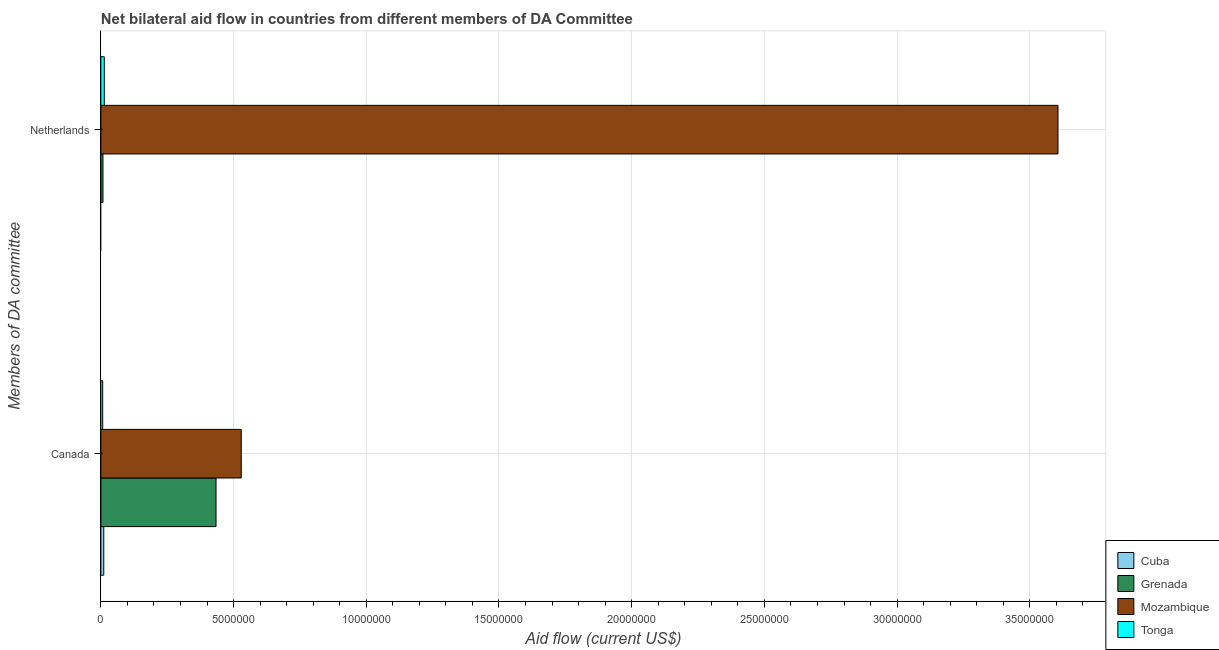How many groups of bars are there?
Offer a very short reply. 2. Are the number of bars per tick equal to the number of legend labels?
Your answer should be very brief. No. What is the amount of aid given by canada in Tonga?
Give a very brief answer. 7.00e+04. Across all countries, what is the maximum amount of aid given by netherlands?
Your answer should be compact. 3.61e+07. In which country was the amount of aid given by canada maximum?
Offer a terse response. Mozambique. What is the total amount of aid given by canada in the graph?
Your response must be concise. 9.81e+06. What is the difference between the amount of aid given by netherlands in Grenada and that in Mozambique?
Offer a terse response. -3.60e+07. What is the difference between the amount of aid given by netherlands in Cuba and the amount of aid given by canada in Mozambique?
Provide a succinct answer. -5.29e+06. What is the average amount of aid given by canada per country?
Keep it short and to the point. 2.45e+06. What is the difference between the amount of aid given by netherlands and amount of aid given by canada in Mozambique?
Your answer should be very brief. 3.08e+07. What is the ratio of the amount of aid given by canada in Tonga to that in Cuba?
Provide a short and direct response. 0.64. Is the amount of aid given by netherlands in Tonga less than that in Mozambique?
Make the answer very short. Yes. In how many countries, is the amount of aid given by netherlands greater than the average amount of aid given by netherlands taken over all countries?
Offer a terse response. 1. Does the graph contain any zero values?
Make the answer very short. Yes. How are the legend labels stacked?
Provide a succinct answer. Vertical. What is the title of the graph?
Your response must be concise. Net bilateral aid flow in countries from different members of DA Committee. What is the label or title of the X-axis?
Your answer should be compact. Aid flow (current US$). What is the label or title of the Y-axis?
Ensure brevity in your answer.  Members of DA committee. What is the Aid flow (current US$) in Grenada in Canada?
Make the answer very short. 4.34e+06. What is the Aid flow (current US$) in Mozambique in Canada?
Your answer should be very brief. 5.29e+06. What is the Aid flow (current US$) of Tonga in Canada?
Ensure brevity in your answer.  7.00e+04. What is the Aid flow (current US$) of Mozambique in Netherlands?
Provide a short and direct response. 3.61e+07. Across all Members of DA committee, what is the maximum Aid flow (current US$) of Grenada?
Keep it short and to the point. 4.34e+06. Across all Members of DA committee, what is the maximum Aid flow (current US$) in Mozambique?
Offer a terse response. 3.61e+07. Across all Members of DA committee, what is the minimum Aid flow (current US$) in Cuba?
Keep it short and to the point. 0. Across all Members of DA committee, what is the minimum Aid flow (current US$) in Mozambique?
Offer a terse response. 5.29e+06. Across all Members of DA committee, what is the minimum Aid flow (current US$) in Tonga?
Offer a terse response. 7.00e+04. What is the total Aid flow (current US$) in Grenada in the graph?
Offer a terse response. 4.42e+06. What is the total Aid flow (current US$) in Mozambique in the graph?
Keep it short and to the point. 4.14e+07. What is the total Aid flow (current US$) of Tonga in the graph?
Your response must be concise. 2.00e+05. What is the difference between the Aid flow (current US$) of Grenada in Canada and that in Netherlands?
Give a very brief answer. 4.26e+06. What is the difference between the Aid flow (current US$) of Mozambique in Canada and that in Netherlands?
Offer a terse response. -3.08e+07. What is the difference between the Aid flow (current US$) in Cuba in Canada and the Aid flow (current US$) in Mozambique in Netherlands?
Offer a terse response. -3.60e+07. What is the difference between the Aid flow (current US$) in Cuba in Canada and the Aid flow (current US$) in Tonga in Netherlands?
Provide a succinct answer. -2.00e+04. What is the difference between the Aid flow (current US$) in Grenada in Canada and the Aid flow (current US$) in Mozambique in Netherlands?
Offer a terse response. -3.17e+07. What is the difference between the Aid flow (current US$) of Grenada in Canada and the Aid flow (current US$) of Tonga in Netherlands?
Offer a very short reply. 4.21e+06. What is the difference between the Aid flow (current US$) in Mozambique in Canada and the Aid flow (current US$) in Tonga in Netherlands?
Ensure brevity in your answer.  5.16e+06. What is the average Aid flow (current US$) of Cuba per Members of DA committee?
Your answer should be very brief. 5.50e+04. What is the average Aid flow (current US$) of Grenada per Members of DA committee?
Keep it short and to the point. 2.21e+06. What is the average Aid flow (current US$) in Mozambique per Members of DA committee?
Offer a terse response. 2.07e+07. What is the average Aid flow (current US$) in Tonga per Members of DA committee?
Your response must be concise. 1.00e+05. What is the difference between the Aid flow (current US$) of Cuba and Aid flow (current US$) of Grenada in Canada?
Your answer should be very brief. -4.23e+06. What is the difference between the Aid flow (current US$) in Cuba and Aid flow (current US$) in Mozambique in Canada?
Your response must be concise. -5.18e+06. What is the difference between the Aid flow (current US$) of Cuba and Aid flow (current US$) of Tonga in Canada?
Your response must be concise. 4.00e+04. What is the difference between the Aid flow (current US$) of Grenada and Aid flow (current US$) of Mozambique in Canada?
Provide a succinct answer. -9.50e+05. What is the difference between the Aid flow (current US$) of Grenada and Aid flow (current US$) of Tonga in Canada?
Give a very brief answer. 4.27e+06. What is the difference between the Aid flow (current US$) in Mozambique and Aid flow (current US$) in Tonga in Canada?
Offer a very short reply. 5.22e+06. What is the difference between the Aid flow (current US$) in Grenada and Aid flow (current US$) in Mozambique in Netherlands?
Provide a succinct answer. -3.60e+07. What is the difference between the Aid flow (current US$) of Grenada and Aid flow (current US$) of Tonga in Netherlands?
Provide a succinct answer. -5.00e+04. What is the difference between the Aid flow (current US$) of Mozambique and Aid flow (current US$) of Tonga in Netherlands?
Keep it short and to the point. 3.59e+07. What is the ratio of the Aid flow (current US$) of Grenada in Canada to that in Netherlands?
Provide a succinct answer. 54.25. What is the ratio of the Aid flow (current US$) in Mozambique in Canada to that in Netherlands?
Offer a very short reply. 0.15. What is the ratio of the Aid flow (current US$) of Tonga in Canada to that in Netherlands?
Give a very brief answer. 0.54. What is the difference between the highest and the second highest Aid flow (current US$) of Grenada?
Keep it short and to the point. 4.26e+06. What is the difference between the highest and the second highest Aid flow (current US$) in Mozambique?
Provide a short and direct response. 3.08e+07. What is the difference between the highest and the second highest Aid flow (current US$) of Tonga?
Offer a terse response. 6.00e+04. What is the difference between the highest and the lowest Aid flow (current US$) in Grenada?
Your response must be concise. 4.26e+06. What is the difference between the highest and the lowest Aid flow (current US$) in Mozambique?
Keep it short and to the point. 3.08e+07. What is the difference between the highest and the lowest Aid flow (current US$) of Tonga?
Provide a short and direct response. 6.00e+04. 